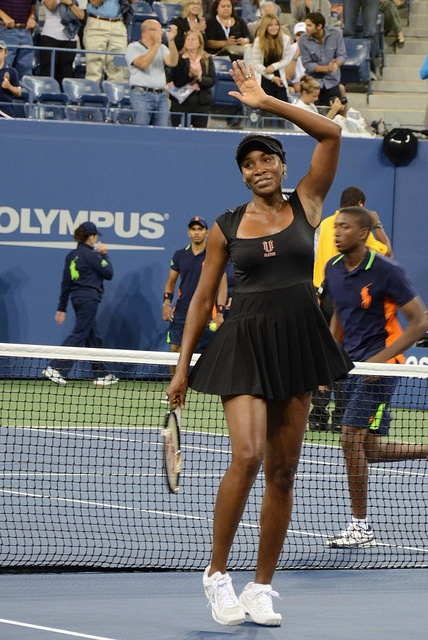Describe the objects in this image and their specific colors. I can see people in black, maroon, and gray tones, people in black, maroon, and gray tones, people in black, darkgray, and gray tones, people in black, gray, and darkgray tones, and people in black, tan, and gray tones in this image. 